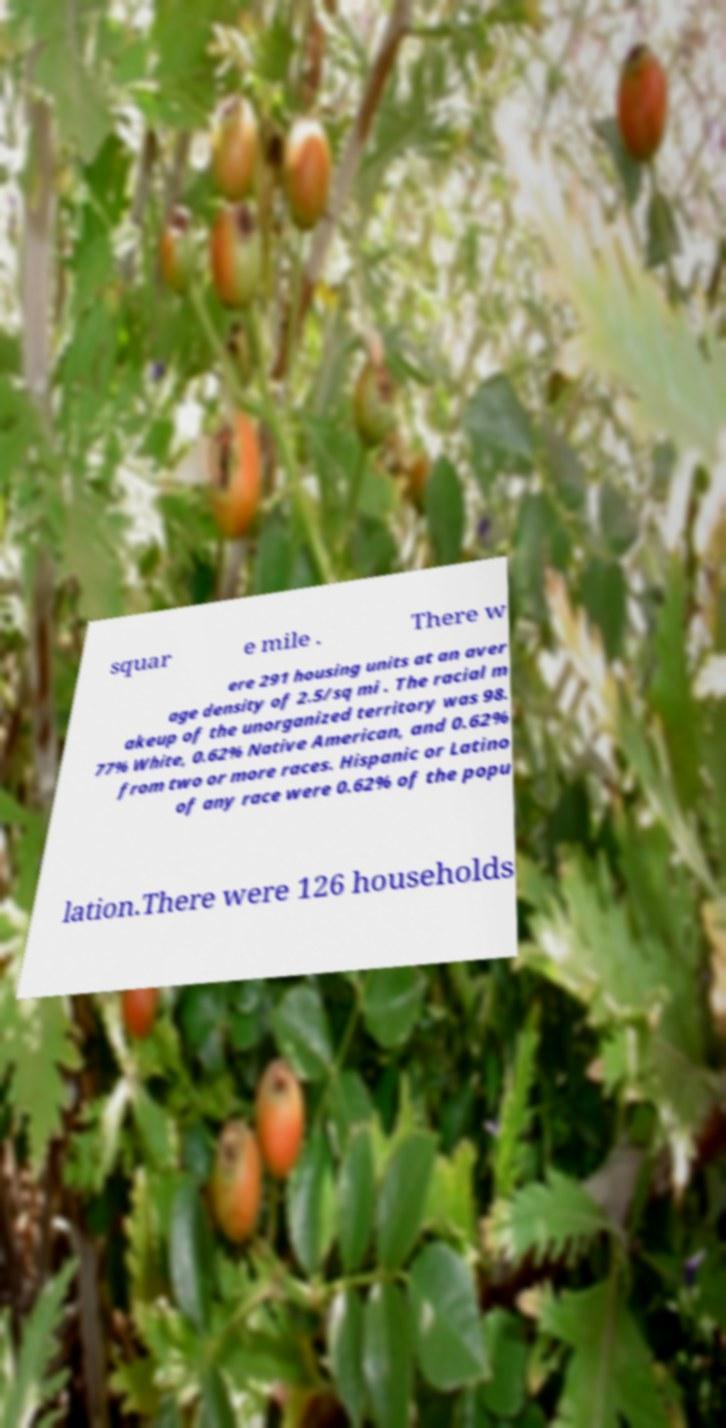Can you accurately transcribe the text from the provided image for me? squar e mile . There w ere 291 housing units at an aver age density of 2.5/sq mi . The racial m akeup of the unorganized territory was 98. 77% White, 0.62% Native American, and 0.62% from two or more races. Hispanic or Latino of any race were 0.62% of the popu lation.There were 126 households 